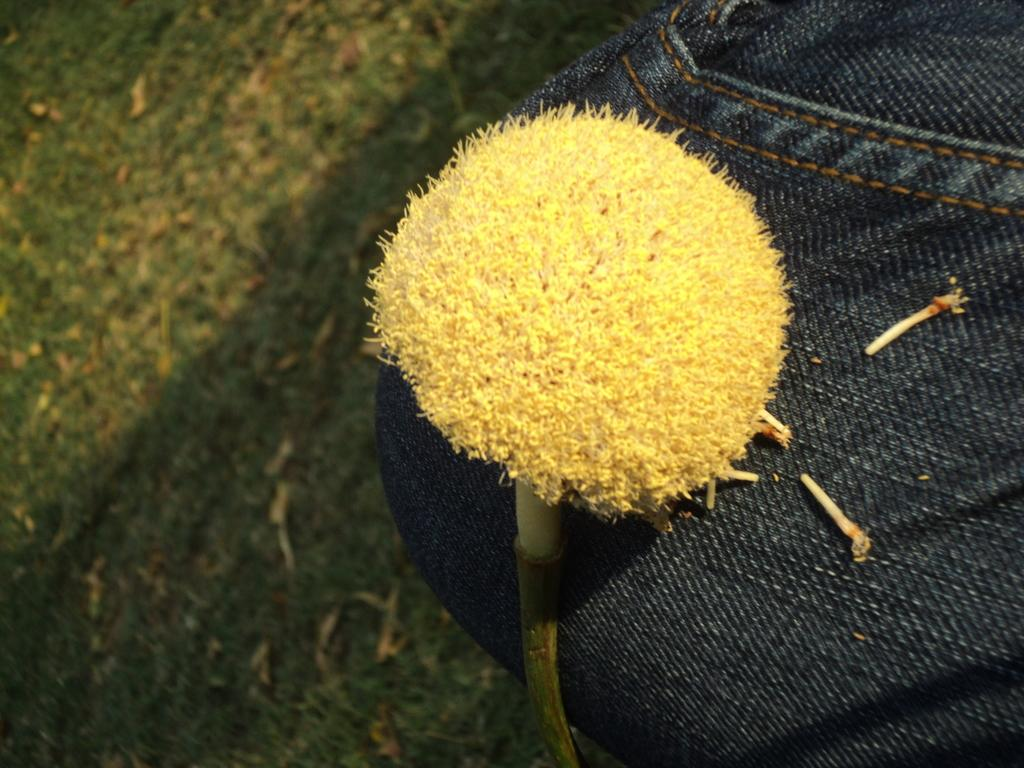What type of flower is present in the image? There is a yellow flower in the image. What type of clothing can be seen in the image? There is a black jean pant in the right corner of the image. What is the ground covered with in the left corner of the image? There is greenery on the ground in the left corner of the image. What type of pain is being experienced by the person in the image? There is no person present in the image, so it is not possible to determine if anyone is experiencing pain. 